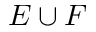<formula> <loc_0><loc_0><loc_500><loc_500>E \cup F</formula> 